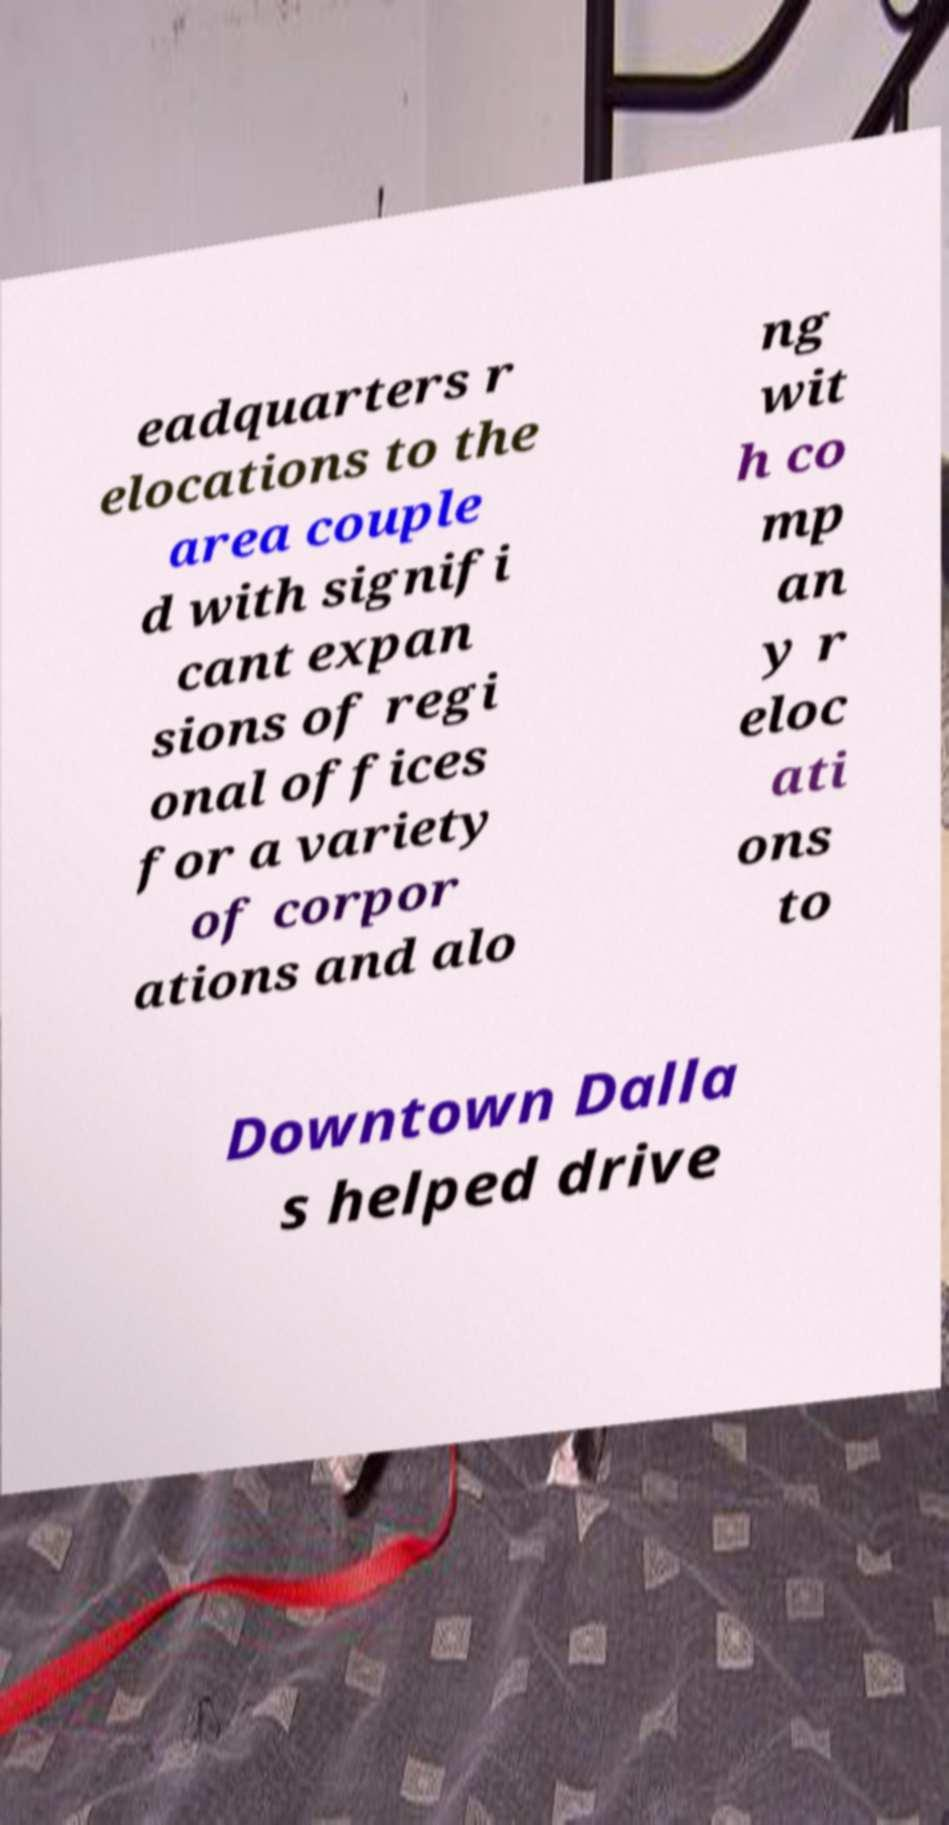I need the written content from this picture converted into text. Can you do that? eadquarters r elocations to the area couple d with signifi cant expan sions of regi onal offices for a variety of corpor ations and alo ng wit h co mp an y r eloc ati ons to Downtown Dalla s helped drive 